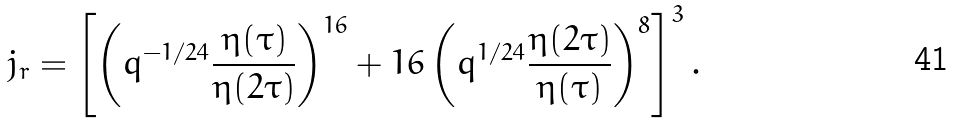Convert formula to latex. <formula><loc_0><loc_0><loc_500><loc_500>j _ { r } = \left [ \left ( q ^ { - 1 / 2 4 } \frac { \eta ( \tau ) } { \eta ( 2 \tau ) } \right ) ^ { 1 6 } + 1 6 \left ( q ^ { 1 / 2 4 } \frac { \eta ( 2 \tau ) } { \eta ( \tau ) } \right ) ^ { 8 } \right ] ^ { 3 } .</formula> 